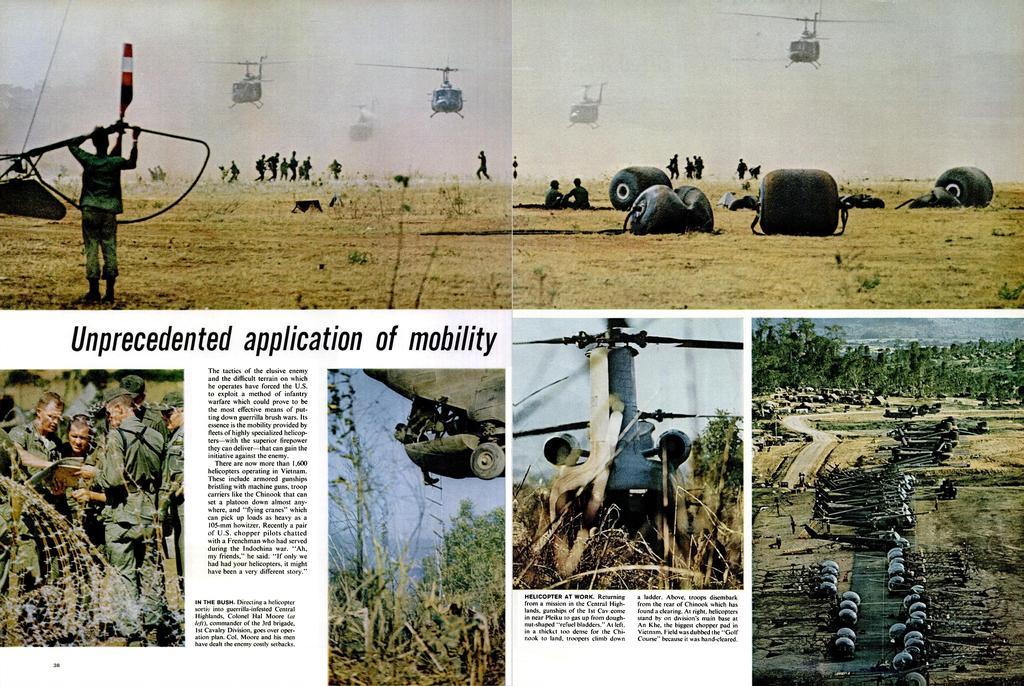Describe this image in one or two sentences. This is a collage image. in this image there are newspaper clippings and there are few photos, in that photos there are helicopters, people and few objects. 